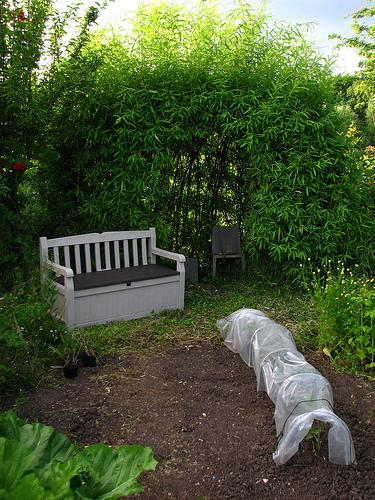What type of chair is present in the image? A brown metal chair is present in the image. Analyze the interaction between the bench with storage and the brown metal chair in the image. The brown metal chair and the bench with storage interact as two seating options situated in the same woody area, providing a relaxing spot amidst nature. Express any emotions or feelings that this image might evoke. The image evokes a sense of tranquility, peace, and appreciation for nature as it showcases a serene environment of plants and trees. Determine the quality of the image based on the positioning and clarity of the objects. The image quality is good as it provides clear information about the positioning and dimensions of multiple objects within the scene. Inspect the image and determine if it requires any complex reasoning tasks. No complex reasoning tasks are required for this image, as it mainly focuses on object detection, description, and analysis. Count the number of different types of plants and flowers mentioned in the image information. There are 7 different types of plants and flowers mentioned in the image information. In a poetic manner, describe the overall scene captured in the image. Amidst a tranquil woody realm, a bench with storage rests, near a nostalgic brown chair; plants, flowers and leaves flourish, while greenhouse guardians keep them safely embraced. Can you find the tree with pink flowers? There is no mention of pink flowers in the image. There are only red and yellow flowers mentioned, so this instruction would lead the user to search for something that doesn't exist in the image. Identify the type of bench in the woody area. Wooden bench with a brown cushion Provide a brief overview of the purpose of the plastic covering and the greenhouse in this image. The purpose is to protect and nurture the growth of the plants inside. How many pots of plants are visible in the image? Two Are there any notable emotions expressed by a person in the image? There are no people in the image Create a summary of the image including the seating and plants. The image shows a wooden bench with a brown cushion, a brown chair, and protected plants covered by plastic in their growing environment. Are there any signs of a special event occurring in the scene? No What is the state of the ground in the image? Gravel and dirt Identify the object under the tree in the image. A brown chair What kind of seating is next to the chair? A wooden bench with a brown cushion Do you see any animals in the scene, such as a dog or a cat? There is no mention of any animals in the image. This instruction is misleading because it asks the user to find something that is not present in the image. Write a poetic description of the scene. In a wooded retreat, amid the dappled greens, life blooms; a tender bench and chair, yet only earth and flora are enthroned. Is the greenhouse also covered by the plastic protective covering for plants? Yes Which of the following colors can be observed in the sky - blue, gray, or both? Both Are there any bicycles leaning against the bench? There is no mention of bicycles in the image. This instruction is misleading because it asks the user to find an object that is not present in the image. Describe the color and material of the chair. Brown, metal Is there a swimming pool in the background behind the plants? There is no mention of a swimming pool in the image. This instruction is misleading because it asks the user to find a feature that is not present in the image. Can you find a white chair to the left of the bench? There is only a brown chair mentioned in the image, not a white one. The instruction is misleading because it incorrectly describes the color of the chair and its position relative to the bench. In this image, what type of plants are covered in plastic? Small plants with yellow flowers What is the purpose of the plastic covering and the greenhouse set up in the image? To protect and help plants grow Describe the scene with a focus on the plants and their environment. A row of plants protected by plastic covering, surrounded by dirt and gravel, with two potted plants nearby, and a patch of yellow flowers. What kind of flowers are growing in the grass? Small yellow flowers Is the chair next to the bench blue and made of metal? The chair in the image is brown, not blue, and there is no mention of it being made of metal. It can be misleading as it incorrectly describes the chair's color and material. 